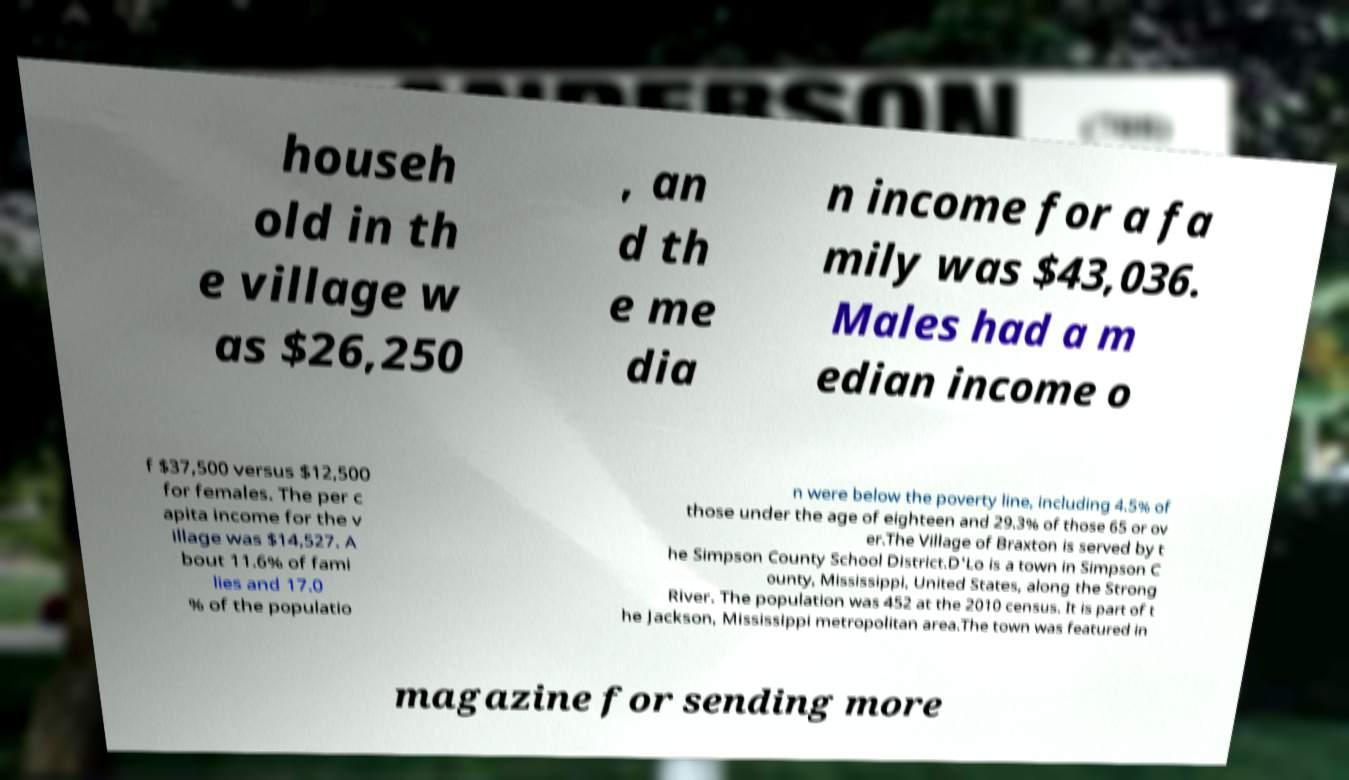Please read and relay the text visible in this image. What does it say? househ old in th e village w as $26,250 , an d th e me dia n income for a fa mily was $43,036. Males had a m edian income o f $37,500 versus $12,500 for females. The per c apita income for the v illage was $14,527. A bout 11.6% of fami lies and 17.0 % of the populatio n were below the poverty line, including 4.5% of those under the age of eighteen and 29.3% of those 65 or ov er.The Village of Braxton is served by t he Simpson County School District.D'Lo is a town in Simpson C ounty, Mississippi, United States, along the Strong River. The population was 452 at the 2010 census. It is part of t he Jackson, Mississippi metropolitan area.The town was featured in magazine for sending more 